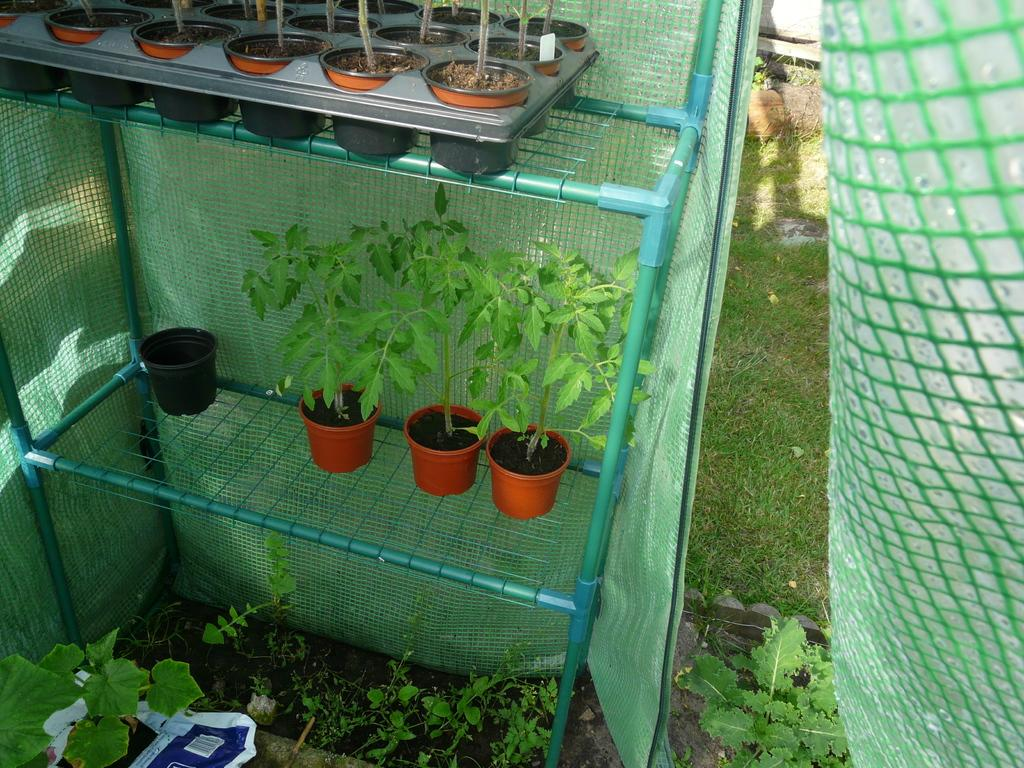What type of objects are present in the image? There are plant pots in the image. Where are the plant pots located? The plant pots are on a green color shelf. What else can be seen in the image besides the plant pots? There are plants visible in the image, as well as grass and other objects. What is the price of the cherry in the image? There is no cherry present in the image, so it is not possible to determine its price. 